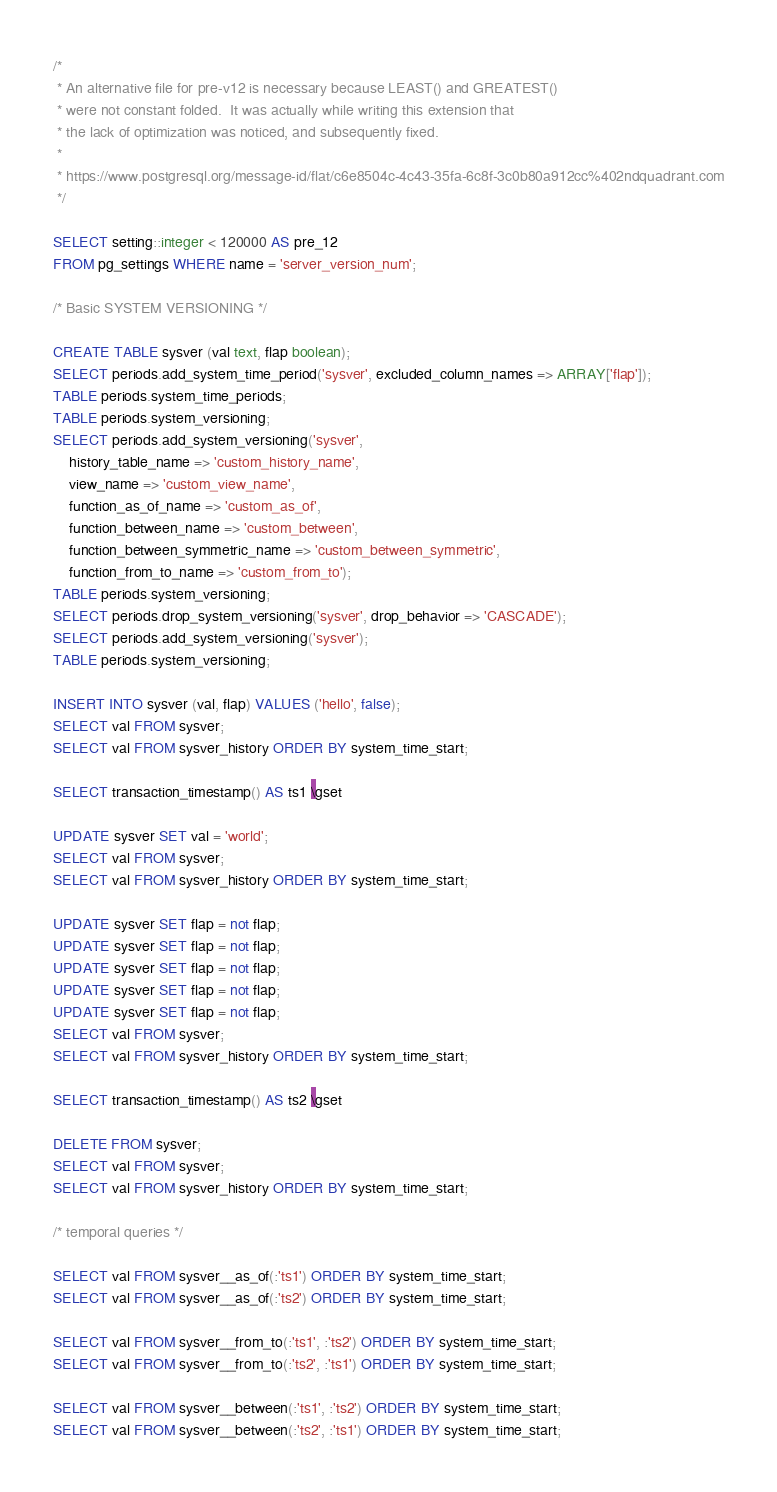Convert code to text. <code><loc_0><loc_0><loc_500><loc_500><_SQL_>/*
 * An alternative file for pre-v12 is necessary because LEAST() and GREATEST()
 * were not constant folded.  It was actually while writing this extension that
 * the lack of optimization was noticed, and subsequently fixed.
 *
 * https://www.postgresql.org/message-id/flat/c6e8504c-4c43-35fa-6c8f-3c0b80a912cc%402ndquadrant.com
 */

SELECT setting::integer < 120000 AS pre_12
FROM pg_settings WHERE name = 'server_version_num';

/* Basic SYSTEM VERSIONING */

CREATE TABLE sysver (val text, flap boolean);
SELECT periods.add_system_time_period('sysver', excluded_column_names => ARRAY['flap']);
TABLE periods.system_time_periods;
TABLE periods.system_versioning;
SELECT periods.add_system_versioning('sysver',
    history_table_name => 'custom_history_name',
    view_name => 'custom_view_name',
    function_as_of_name => 'custom_as_of',
    function_between_name => 'custom_between',
    function_between_symmetric_name => 'custom_between_symmetric',
    function_from_to_name => 'custom_from_to');
TABLE periods.system_versioning;
SELECT periods.drop_system_versioning('sysver', drop_behavior => 'CASCADE');
SELECT periods.add_system_versioning('sysver');
TABLE periods.system_versioning;

INSERT INTO sysver (val, flap) VALUES ('hello', false);
SELECT val FROM sysver;
SELECT val FROM sysver_history ORDER BY system_time_start;

SELECT transaction_timestamp() AS ts1 \gset

UPDATE sysver SET val = 'world';
SELECT val FROM sysver;
SELECT val FROM sysver_history ORDER BY system_time_start;

UPDATE sysver SET flap = not flap;
UPDATE sysver SET flap = not flap;
UPDATE sysver SET flap = not flap;
UPDATE sysver SET flap = not flap;
UPDATE sysver SET flap = not flap;
SELECT val FROM sysver;
SELECT val FROM sysver_history ORDER BY system_time_start;

SELECT transaction_timestamp() AS ts2 \gset

DELETE FROM sysver;
SELECT val FROM sysver;
SELECT val FROM sysver_history ORDER BY system_time_start;

/* temporal queries */

SELECT val FROM sysver__as_of(:'ts1') ORDER BY system_time_start;
SELECT val FROM sysver__as_of(:'ts2') ORDER BY system_time_start;

SELECT val FROM sysver__from_to(:'ts1', :'ts2') ORDER BY system_time_start;
SELECT val FROM sysver__from_to(:'ts2', :'ts1') ORDER BY system_time_start;

SELECT val FROM sysver__between(:'ts1', :'ts2') ORDER BY system_time_start;
SELECT val FROM sysver__between(:'ts2', :'ts1') ORDER BY system_time_start;
</code> 